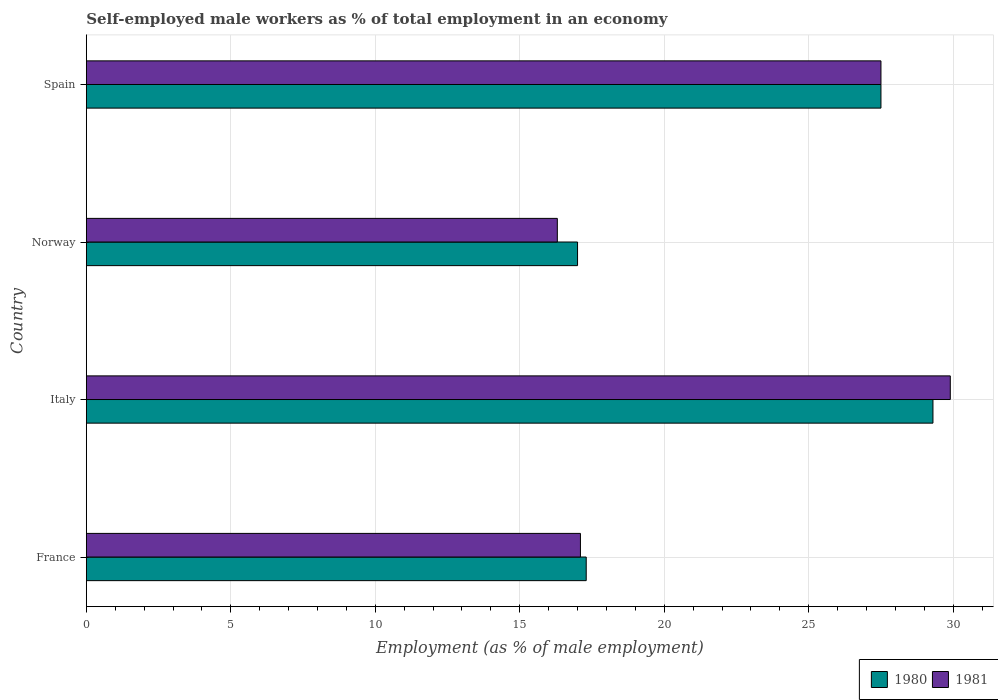How many bars are there on the 2nd tick from the bottom?
Offer a terse response. 2. What is the percentage of self-employed male workers in 1981 in Spain?
Offer a terse response. 27.5. Across all countries, what is the maximum percentage of self-employed male workers in 1981?
Your answer should be compact. 29.9. Across all countries, what is the minimum percentage of self-employed male workers in 1981?
Your answer should be compact. 16.3. In which country was the percentage of self-employed male workers in 1981 maximum?
Provide a succinct answer. Italy. What is the total percentage of self-employed male workers in 1981 in the graph?
Offer a terse response. 90.8. What is the difference between the percentage of self-employed male workers in 1980 in Italy and the percentage of self-employed male workers in 1981 in Norway?
Provide a succinct answer. 13. What is the average percentage of self-employed male workers in 1980 per country?
Make the answer very short. 22.77. What is the difference between the percentage of self-employed male workers in 1981 and percentage of self-employed male workers in 1980 in Spain?
Offer a very short reply. 0. What is the ratio of the percentage of self-employed male workers in 1981 in France to that in Italy?
Ensure brevity in your answer.  0.57. Is the difference between the percentage of self-employed male workers in 1981 in Italy and Spain greater than the difference between the percentage of self-employed male workers in 1980 in Italy and Spain?
Offer a terse response. Yes. What is the difference between the highest and the second highest percentage of self-employed male workers in 1980?
Keep it short and to the point. 1.8. What is the difference between the highest and the lowest percentage of self-employed male workers in 1981?
Offer a very short reply. 13.6. How many bars are there?
Your response must be concise. 8. How many countries are there in the graph?
Provide a succinct answer. 4. What is the difference between two consecutive major ticks on the X-axis?
Offer a very short reply. 5. Does the graph contain any zero values?
Ensure brevity in your answer.  No. Where does the legend appear in the graph?
Your response must be concise. Bottom right. What is the title of the graph?
Provide a short and direct response. Self-employed male workers as % of total employment in an economy. Does "1983" appear as one of the legend labels in the graph?
Provide a succinct answer. No. What is the label or title of the X-axis?
Provide a succinct answer. Employment (as % of male employment). What is the Employment (as % of male employment) in 1980 in France?
Your answer should be very brief. 17.3. What is the Employment (as % of male employment) of 1981 in France?
Your answer should be compact. 17.1. What is the Employment (as % of male employment) in 1980 in Italy?
Your answer should be very brief. 29.3. What is the Employment (as % of male employment) of 1981 in Italy?
Keep it short and to the point. 29.9. What is the Employment (as % of male employment) in 1981 in Norway?
Provide a short and direct response. 16.3. What is the Employment (as % of male employment) of 1980 in Spain?
Provide a short and direct response. 27.5. Across all countries, what is the maximum Employment (as % of male employment) of 1980?
Provide a succinct answer. 29.3. Across all countries, what is the maximum Employment (as % of male employment) in 1981?
Keep it short and to the point. 29.9. Across all countries, what is the minimum Employment (as % of male employment) of 1980?
Keep it short and to the point. 17. Across all countries, what is the minimum Employment (as % of male employment) of 1981?
Your response must be concise. 16.3. What is the total Employment (as % of male employment) of 1980 in the graph?
Your answer should be very brief. 91.1. What is the total Employment (as % of male employment) of 1981 in the graph?
Keep it short and to the point. 90.8. What is the difference between the Employment (as % of male employment) of 1980 in France and that in Italy?
Your answer should be compact. -12. What is the difference between the Employment (as % of male employment) of 1981 in France and that in Italy?
Ensure brevity in your answer.  -12.8. What is the difference between the Employment (as % of male employment) of 1980 in France and that in Norway?
Keep it short and to the point. 0.3. What is the difference between the Employment (as % of male employment) in 1981 in France and that in Norway?
Your response must be concise. 0.8. What is the difference between the Employment (as % of male employment) in 1980 in France and that in Spain?
Your answer should be compact. -10.2. What is the difference between the Employment (as % of male employment) in 1980 in Italy and that in Norway?
Offer a very short reply. 12.3. What is the difference between the Employment (as % of male employment) of 1981 in Italy and that in Spain?
Provide a short and direct response. 2.4. What is the difference between the Employment (as % of male employment) of 1980 in Norway and that in Spain?
Your response must be concise. -10.5. What is the difference between the Employment (as % of male employment) in 1981 in Norway and that in Spain?
Give a very brief answer. -11.2. What is the difference between the Employment (as % of male employment) in 1980 in France and the Employment (as % of male employment) in 1981 in Italy?
Your answer should be compact. -12.6. What is the difference between the Employment (as % of male employment) of 1980 in France and the Employment (as % of male employment) of 1981 in Norway?
Give a very brief answer. 1. What is the difference between the Employment (as % of male employment) in 1980 in France and the Employment (as % of male employment) in 1981 in Spain?
Provide a short and direct response. -10.2. What is the difference between the Employment (as % of male employment) of 1980 in Norway and the Employment (as % of male employment) of 1981 in Spain?
Your answer should be very brief. -10.5. What is the average Employment (as % of male employment) in 1980 per country?
Provide a short and direct response. 22.77. What is the average Employment (as % of male employment) of 1981 per country?
Provide a short and direct response. 22.7. What is the difference between the Employment (as % of male employment) in 1980 and Employment (as % of male employment) in 1981 in France?
Ensure brevity in your answer.  0.2. What is the difference between the Employment (as % of male employment) in 1980 and Employment (as % of male employment) in 1981 in Italy?
Keep it short and to the point. -0.6. What is the difference between the Employment (as % of male employment) of 1980 and Employment (as % of male employment) of 1981 in Norway?
Offer a terse response. 0.7. What is the difference between the Employment (as % of male employment) of 1980 and Employment (as % of male employment) of 1981 in Spain?
Provide a succinct answer. 0. What is the ratio of the Employment (as % of male employment) in 1980 in France to that in Italy?
Your answer should be compact. 0.59. What is the ratio of the Employment (as % of male employment) of 1981 in France to that in Italy?
Offer a very short reply. 0.57. What is the ratio of the Employment (as % of male employment) in 1980 in France to that in Norway?
Your response must be concise. 1.02. What is the ratio of the Employment (as % of male employment) in 1981 in France to that in Norway?
Provide a short and direct response. 1.05. What is the ratio of the Employment (as % of male employment) in 1980 in France to that in Spain?
Your answer should be very brief. 0.63. What is the ratio of the Employment (as % of male employment) of 1981 in France to that in Spain?
Ensure brevity in your answer.  0.62. What is the ratio of the Employment (as % of male employment) in 1980 in Italy to that in Norway?
Provide a succinct answer. 1.72. What is the ratio of the Employment (as % of male employment) of 1981 in Italy to that in Norway?
Ensure brevity in your answer.  1.83. What is the ratio of the Employment (as % of male employment) in 1980 in Italy to that in Spain?
Provide a short and direct response. 1.07. What is the ratio of the Employment (as % of male employment) of 1981 in Italy to that in Spain?
Keep it short and to the point. 1.09. What is the ratio of the Employment (as % of male employment) in 1980 in Norway to that in Spain?
Make the answer very short. 0.62. What is the ratio of the Employment (as % of male employment) of 1981 in Norway to that in Spain?
Your answer should be very brief. 0.59. What is the difference between the highest and the second highest Employment (as % of male employment) in 1980?
Offer a very short reply. 1.8. What is the difference between the highest and the second highest Employment (as % of male employment) in 1981?
Provide a succinct answer. 2.4. 